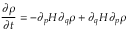<formula> <loc_0><loc_0><loc_500><loc_500>\frac { \partial \rho } { \partial t } = - \partial _ { p } H \partial _ { q } \rho + \partial _ { q } H \partial _ { p } \rho</formula> 